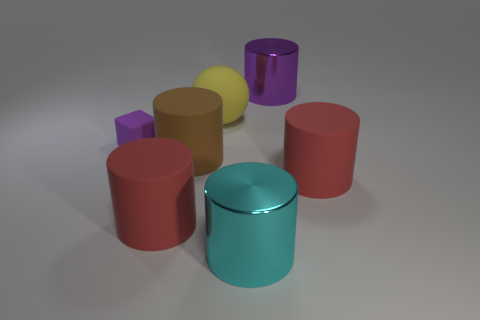Subtract all cyan cylinders. How many cylinders are left? 4 Subtract all gray balls. How many red cylinders are left? 2 Subtract all purple cylinders. How many cylinders are left? 4 Subtract 2 cylinders. How many cylinders are left? 3 Add 1 purple matte objects. How many objects exist? 8 Subtract all cubes. How many objects are left? 6 Add 4 purple rubber cylinders. How many purple rubber cylinders exist? 4 Subtract 0 brown balls. How many objects are left? 7 Subtract all yellow cylinders. Subtract all yellow blocks. How many cylinders are left? 5 Subtract all big cylinders. Subtract all red rubber cylinders. How many objects are left? 0 